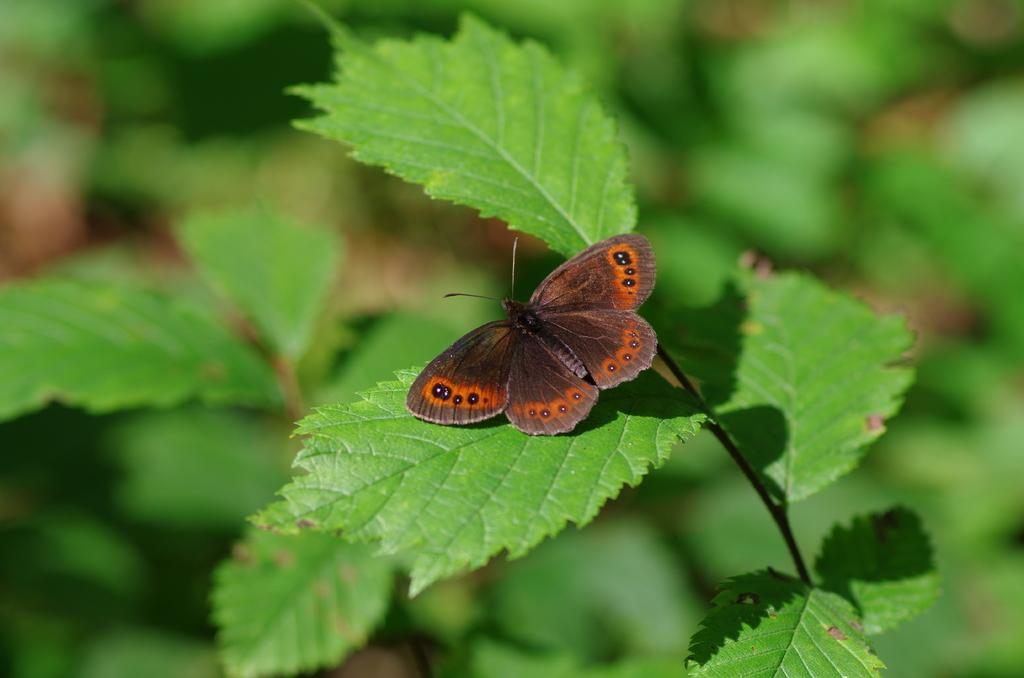What is the main subject of the image? The main subject of the image is the many plants. Can you describe any specific details about the plants? There is a butterfly sitting on a leaf in the image. What can be observed about the background of the image? The background of the image is blurred. What grade does the apple receive in the image? There is no apple present in the image, so it cannot receive a grade. 